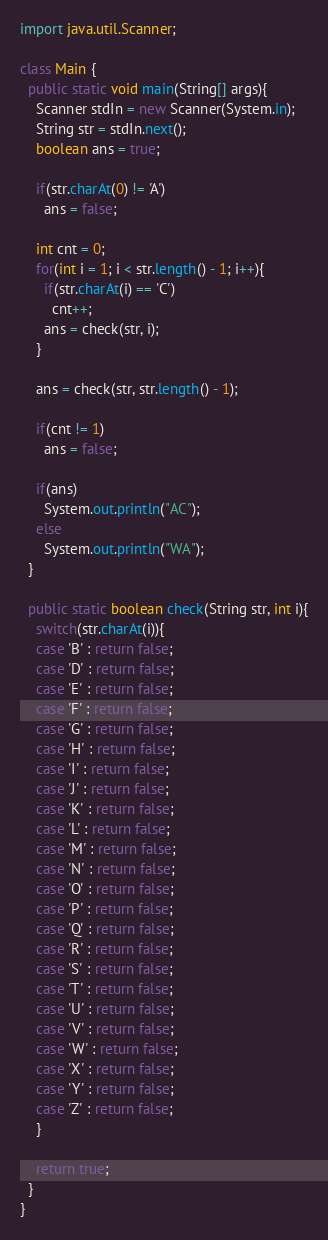Convert code to text. <code><loc_0><loc_0><loc_500><loc_500><_Java_>import java.util.Scanner;

class Main {
  public static void main(String[] args){
    Scanner stdIn = new Scanner(System.in);
    String str = stdIn.next();
    boolean ans = true;

    if(str.charAt(0) != 'A')
      ans = false;

    int cnt = 0;
    for(int i = 1; i < str.length() - 1; i++){
      if(str.charAt(i) == 'C')
        cnt++;
      ans = check(str, i);
    }
    
    ans = check(str, str.length() - 1);
   
    if(cnt != 1)
      ans = false;

    if(ans)
      System.out.println("AC");
    else
      System.out.println("WA");
  }

  public static boolean check(String str, int i){
    switch(str.charAt(i)){
    case 'B' : return false;
    case 'D' : return false;
    case 'E' : return false;
    case 'F' : return false;
    case 'G' : return false;
    case 'H' : return false;
    case 'I' : return false;
    case 'J' : return false;
    case 'K' : return false;
    case 'L' : return false;
    case 'M' : return false;
    case 'N' : return false;
    case 'O' : return false;
    case 'P' : return false;
    case 'Q' : return false;
    case 'R' : return false;
    case 'S' : return false;
    case 'T' : return false;
    case 'U' : return false;
    case 'V' : return false;
    case 'W' : return false;
    case 'X' : return false;
    case 'Y' : return false;
    case 'Z' : return false;
    }

    return true;
  }
}</code> 